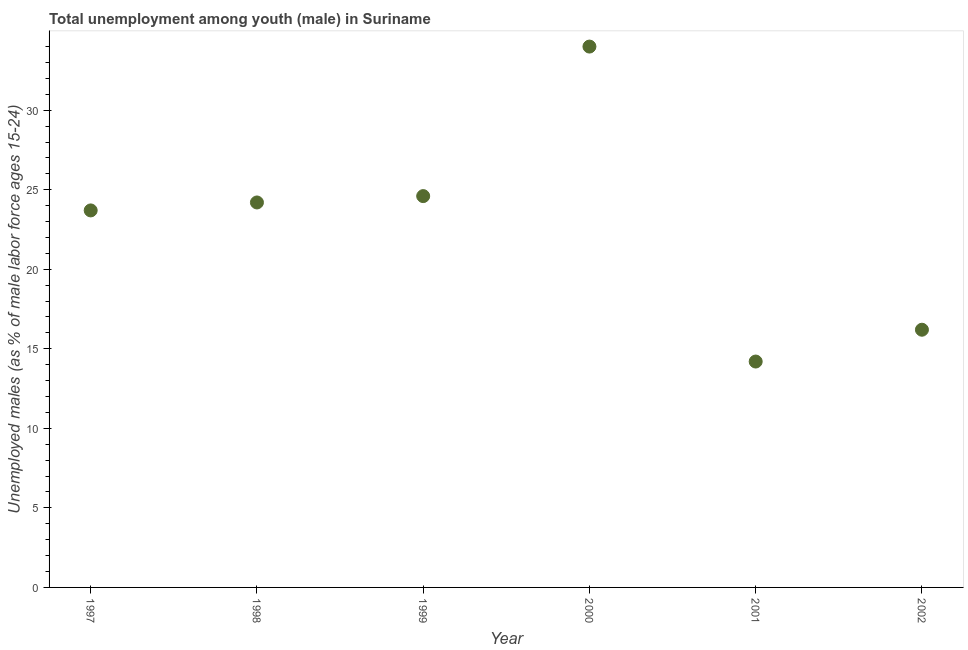What is the unemployed male youth population in 2001?
Your answer should be very brief. 14.2. Across all years, what is the maximum unemployed male youth population?
Keep it short and to the point. 34. Across all years, what is the minimum unemployed male youth population?
Your answer should be compact. 14.2. In which year was the unemployed male youth population maximum?
Ensure brevity in your answer.  2000. What is the sum of the unemployed male youth population?
Give a very brief answer. 136.9. What is the difference between the unemployed male youth population in 1999 and 2002?
Ensure brevity in your answer.  8.4. What is the average unemployed male youth population per year?
Make the answer very short. 22.82. What is the median unemployed male youth population?
Provide a succinct answer. 23.95. What is the ratio of the unemployed male youth population in 1999 to that in 2002?
Your answer should be very brief. 1.52. Is the unemployed male youth population in 1998 less than that in 1999?
Give a very brief answer. Yes. Is the difference between the unemployed male youth population in 1997 and 2001 greater than the difference between any two years?
Offer a terse response. No. What is the difference between the highest and the second highest unemployed male youth population?
Keep it short and to the point. 9.4. Is the sum of the unemployed male youth population in 1997 and 1999 greater than the maximum unemployed male youth population across all years?
Provide a short and direct response. Yes. What is the difference between the highest and the lowest unemployed male youth population?
Offer a very short reply. 19.8. Does the unemployed male youth population monotonically increase over the years?
Your answer should be very brief. No. How many dotlines are there?
Give a very brief answer. 1. What is the difference between two consecutive major ticks on the Y-axis?
Provide a short and direct response. 5. Does the graph contain grids?
Offer a terse response. No. What is the title of the graph?
Your answer should be compact. Total unemployment among youth (male) in Suriname. What is the label or title of the Y-axis?
Offer a terse response. Unemployed males (as % of male labor force ages 15-24). What is the Unemployed males (as % of male labor force ages 15-24) in 1997?
Your answer should be compact. 23.7. What is the Unemployed males (as % of male labor force ages 15-24) in 1998?
Offer a terse response. 24.2. What is the Unemployed males (as % of male labor force ages 15-24) in 1999?
Your response must be concise. 24.6. What is the Unemployed males (as % of male labor force ages 15-24) in 2000?
Give a very brief answer. 34. What is the Unemployed males (as % of male labor force ages 15-24) in 2001?
Provide a short and direct response. 14.2. What is the Unemployed males (as % of male labor force ages 15-24) in 2002?
Ensure brevity in your answer.  16.2. What is the difference between the Unemployed males (as % of male labor force ages 15-24) in 1997 and 2000?
Provide a succinct answer. -10.3. What is the difference between the Unemployed males (as % of male labor force ages 15-24) in 1997 and 2002?
Provide a short and direct response. 7.5. What is the difference between the Unemployed males (as % of male labor force ages 15-24) in 1998 and 2000?
Provide a short and direct response. -9.8. What is the difference between the Unemployed males (as % of male labor force ages 15-24) in 1998 and 2001?
Offer a terse response. 10. What is the difference between the Unemployed males (as % of male labor force ages 15-24) in 1998 and 2002?
Your response must be concise. 8. What is the difference between the Unemployed males (as % of male labor force ages 15-24) in 1999 and 2001?
Offer a terse response. 10.4. What is the difference between the Unemployed males (as % of male labor force ages 15-24) in 2000 and 2001?
Your answer should be very brief. 19.8. What is the difference between the Unemployed males (as % of male labor force ages 15-24) in 2000 and 2002?
Keep it short and to the point. 17.8. What is the difference between the Unemployed males (as % of male labor force ages 15-24) in 2001 and 2002?
Offer a terse response. -2. What is the ratio of the Unemployed males (as % of male labor force ages 15-24) in 1997 to that in 2000?
Offer a terse response. 0.7. What is the ratio of the Unemployed males (as % of male labor force ages 15-24) in 1997 to that in 2001?
Provide a succinct answer. 1.67. What is the ratio of the Unemployed males (as % of male labor force ages 15-24) in 1997 to that in 2002?
Your response must be concise. 1.46. What is the ratio of the Unemployed males (as % of male labor force ages 15-24) in 1998 to that in 1999?
Provide a succinct answer. 0.98. What is the ratio of the Unemployed males (as % of male labor force ages 15-24) in 1998 to that in 2000?
Your response must be concise. 0.71. What is the ratio of the Unemployed males (as % of male labor force ages 15-24) in 1998 to that in 2001?
Give a very brief answer. 1.7. What is the ratio of the Unemployed males (as % of male labor force ages 15-24) in 1998 to that in 2002?
Your answer should be very brief. 1.49. What is the ratio of the Unemployed males (as % of male labor force ages 15-24) in 1999 to that in 2000?
Make the answer very short. 0.72. What is the ratio of the Unemployed males (as % of male labor force ages 15-24) in 1999 to that in 2001?
Ensure brevity in your answer.  1.73. What is the ratio of the Unemployed males (as % of male labor force ages 15-24) in 1999 to that in 2002?
Provide a succinct answer. 1.52. What is the ratio of the Unemployed males (as % of male labor force ages 15-24) in 2000 to that in 2001?
Your answer should be very brief. 2.39. What is the ratio of the Unemployed males (as % of male labor force ages 15-24) in 2000 to that in 2002?
Give a very brief answer. 2.1. What is the ratio of the Unemployed males (as % of male labor force ages 15-24) in 2001 to that in 2002?
Your answer should be compact. 0.88. 